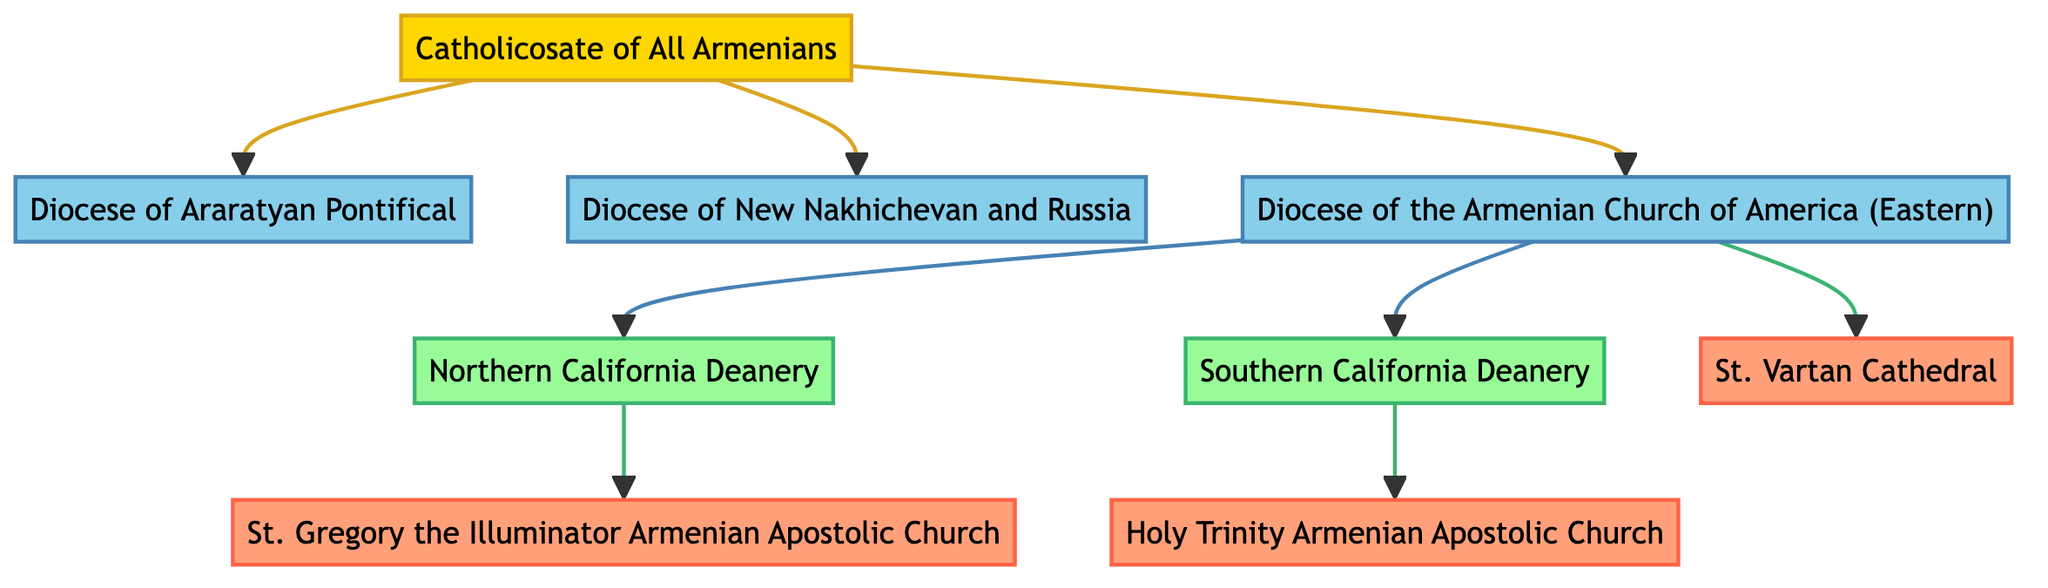What is the central authority in the hierarchical structure? The central authority node in the diagram is labeled "Catholicosate of All Armenians." It acts as the top-level entity from which the dioceses are administered.
Answer: Catholicosate of All Armenians How many dioceses are directly connected to the Catholicosate? The diagram shows three edges leading from the Catholicosate to three different dioceses, indicating a direct connection between them. These dioceses are: Diocese of Araratyan Pontifical, Diocese of New Nakhichevan and Russia, and Diocese of the Armenian Church of America (Eastern).
Answer: 3 Which deanery is connected to the Northern California Deanery? The Northern California Deanery is a child node directly connected to Diocese of the Armenian Church of America (Eastern), indicated by an administrative relationship. There are no further connections to other nodes for this deanery in the diagram.
Answer: Diocese of the Armenian Church of America (Eastern) How many local parishes are under the Southern California Deanery? The diagram illustrates one local parish connected to the Southern California Deanery, specifically labeled as Holy Trinity Armenian Apostolic Church. This indicates that there is only one parish under that deanery.
Answer: 1 What type of relationship exists between the Catholicosate and the dioceses? The relationship between the Catholicosate and the dioceses is classified as "administrative," suggesting a hierarchical control or oversight function from the Catholicosate over the dioceses.
Answer: Administrative Which parish is not associated with any deanery? Upon reviewing the connections, St. Vartan Cathedral is directly connected to the Diocese of the Armenian Church of America (Eastern) but does not have any further connection to a deanery.
Answer: St. Vartan Cathedral How many total edges are present in the diagram? By analyzing the edges, we can count each connection: three from the Catholicosate to the dioceses, two from the Diocese of the Armenian Church of America (Eastern) to the deaneries, and three from the deaneries to the parishes. Adding these gives us a total of eight edges.
Answer: 8 Which type of node is the Southern California Deanery? The Southern California Deanery node is labeled as a "deanery" in the diagram, which categorizes it within the structure of the Armenian Orthodox Church as a governing division under the dioceses.
Answer: Deanery 